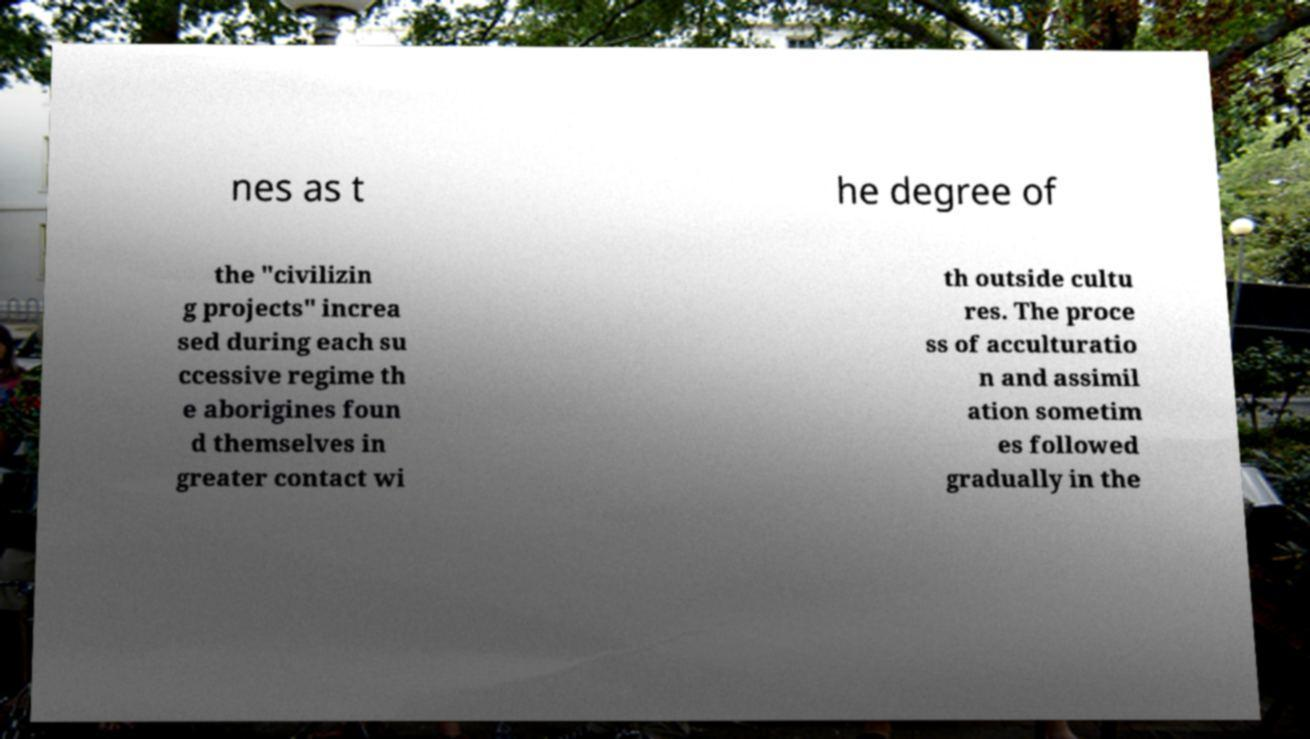There's text embedded in this image that I need extracted. Can you transcribe it verbatim? nes as t he degree of the "civilizin g projects" increa sed during each su ccessive regime th e aborigines foun d themselves in greater contact wi th outside cultu res. The proce ss of acculturatio n and assimil ation sometim es followed gradually in the 